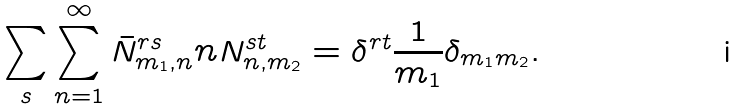Convert formula to latex. <formula><loc_0><loc_0><loc_500><loc_500>\sum _ { s } \sum _ { n = 1 } ^ { \infty } \bar { N } ^ { r s } _ { m _ { 1 } , n } n N ^ { s t } _ { n , m _ { 2 } } = \delta ^ { r t } \frac { 1 } { m _ { 1 } } \delta _ { m _ { 1 } m _ { 2 } } .</formula> 